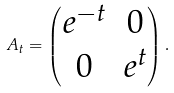<formula> <loc_0><loc_0><loc_500><loc_500>A _ { t } = \begin{pmatrix} e ^ { - t } & 0 \\ 0 & e ^ { t } \end{pmatrix} .</formula> 